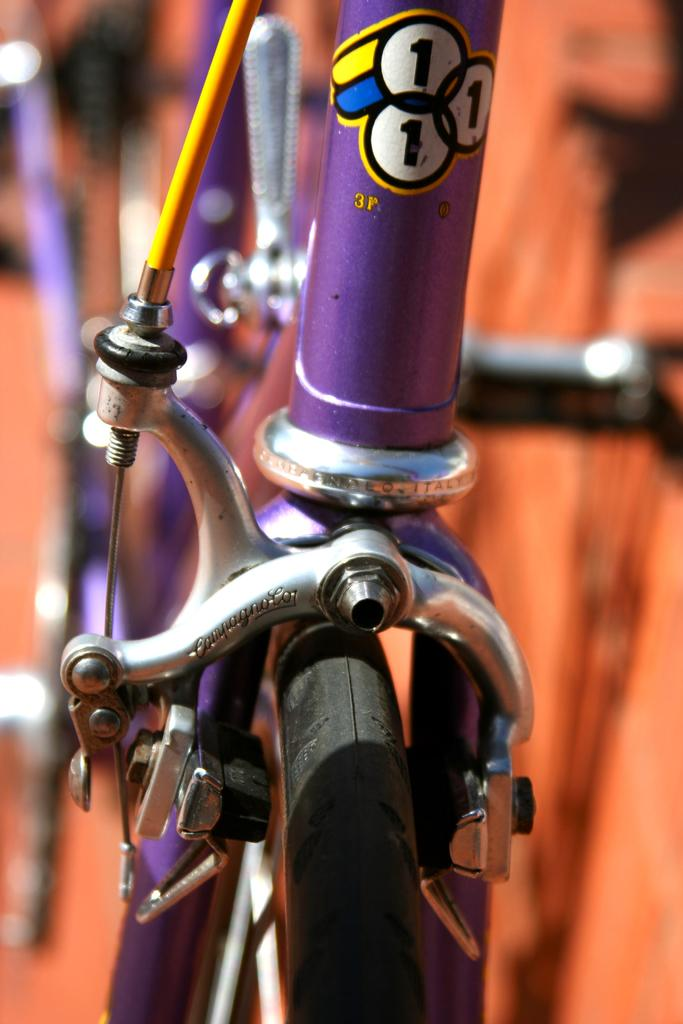What is the main subject of the image? The main subject of the image is a cycle front wheel brake arm. Can you describe the location of the brake arm in the image? The cycle front wheel brake arm is in the center of the image. How many beds are visible in the image? There are no beds present in the image; it features a cycle front wheel brake arm. What type of railway infrastructure can be seen in the image? There is no railway infrastructure present in the image; it features a cycle front wheel brake arm. 